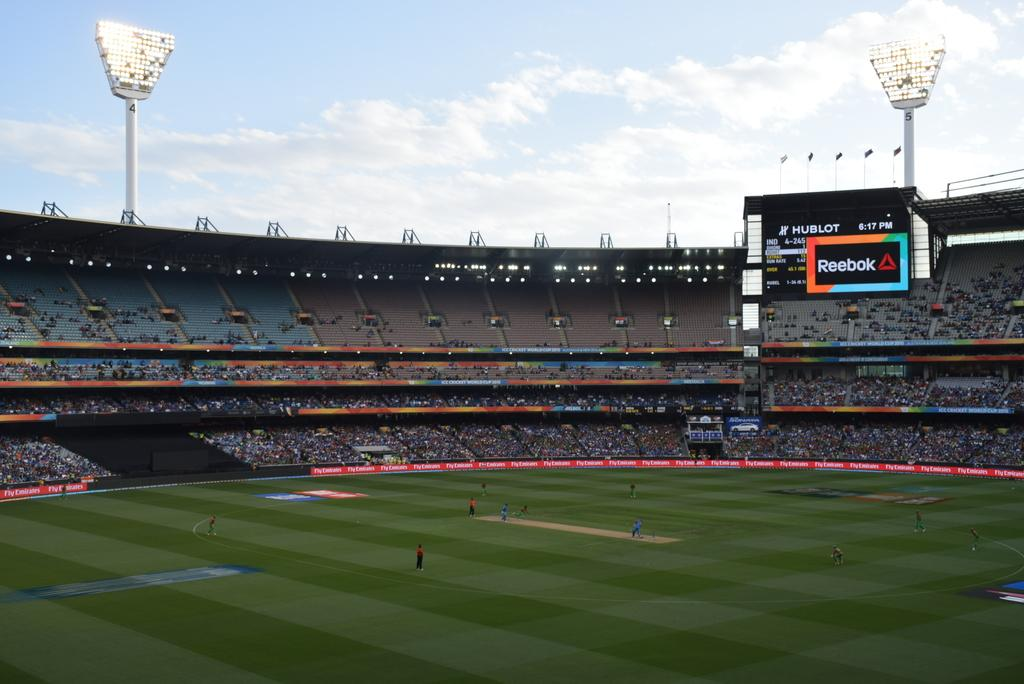<image>
Create a compact narrative representing the image presented. An outdoor arena where people are playing a game and a sign about Reebok is near the top of the arena. 